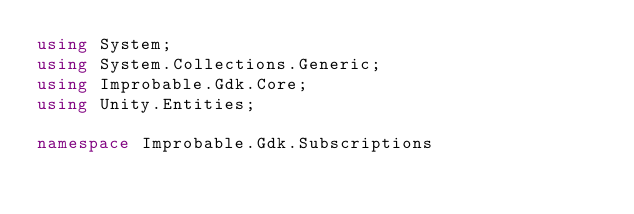<code> <loc_0><loc_0><loc_500><loc_500><_C#_>using System;
using System.Collections.Generic;
using Improbable.Gdk.Core;
using Unity.Entities;

namespace Improbable.Gdk.Subscriptions</code> 